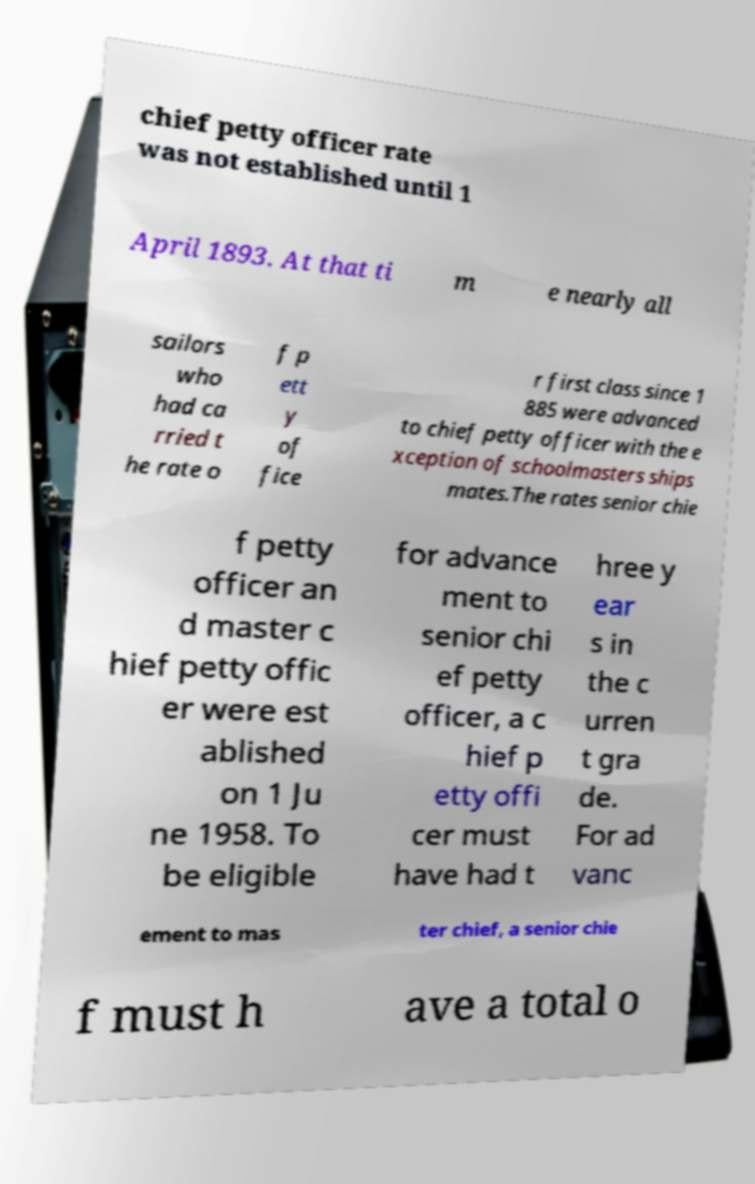Could you assist in decoding the text presented in this image and type it out clearly? chief petty officer rate was not established until 1 April 1893. At that ti m e nearly all sailors who had ca rried t he rate o f p ett y of fice r first class since 1 885 were advanced to chief petty officer with the e xception of schoolmasters ships mates.The rates senior chie f petty officer an d master c hief petty offic er were est ablished on 1 Ju ne 1958. To be eligible for advance ment to senior chi ef petty officer, a c hief p etty offi cer must have had t hree y ear s in the c urren t gra de. For ad vanc ement to mas ter chief, a senior chie f must h ave a total o 